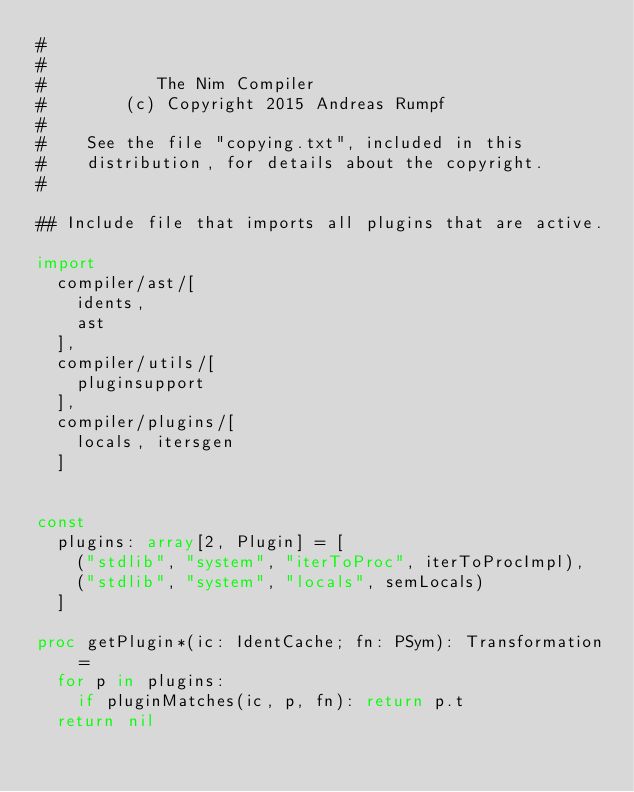<code> <loc_0><loc_0><loc_500><loc_500><_Nim_>#
#
#           The Nim Compiler
#        (c) Copyright 2015 Andreas Rumpf
#
#    See the file "copying.txt", included in this
#    distribution, for details about the copyright.
#

## Include file that imports all plugins that are active.

import
  compiler/ast/[
    idents,
    ast
  ],
  compiler/utils/[
    pluginsupport
  ],
  compiler/plugins/[
    locals, itersgen
  ]


const
  plugins: array[2, Plugin] = [
    ("stdlib", "system", "iterToProc", iterToProcImpl),
    ("stdlib", "system", "locals", semLocals)
  ]

proc getPlugin*(ic: IdentCache; fn: PSym): Transformation =
  for p in plugins:
    if pluginMatches(ic, p, fn): return p.t
  return nil
</code> 